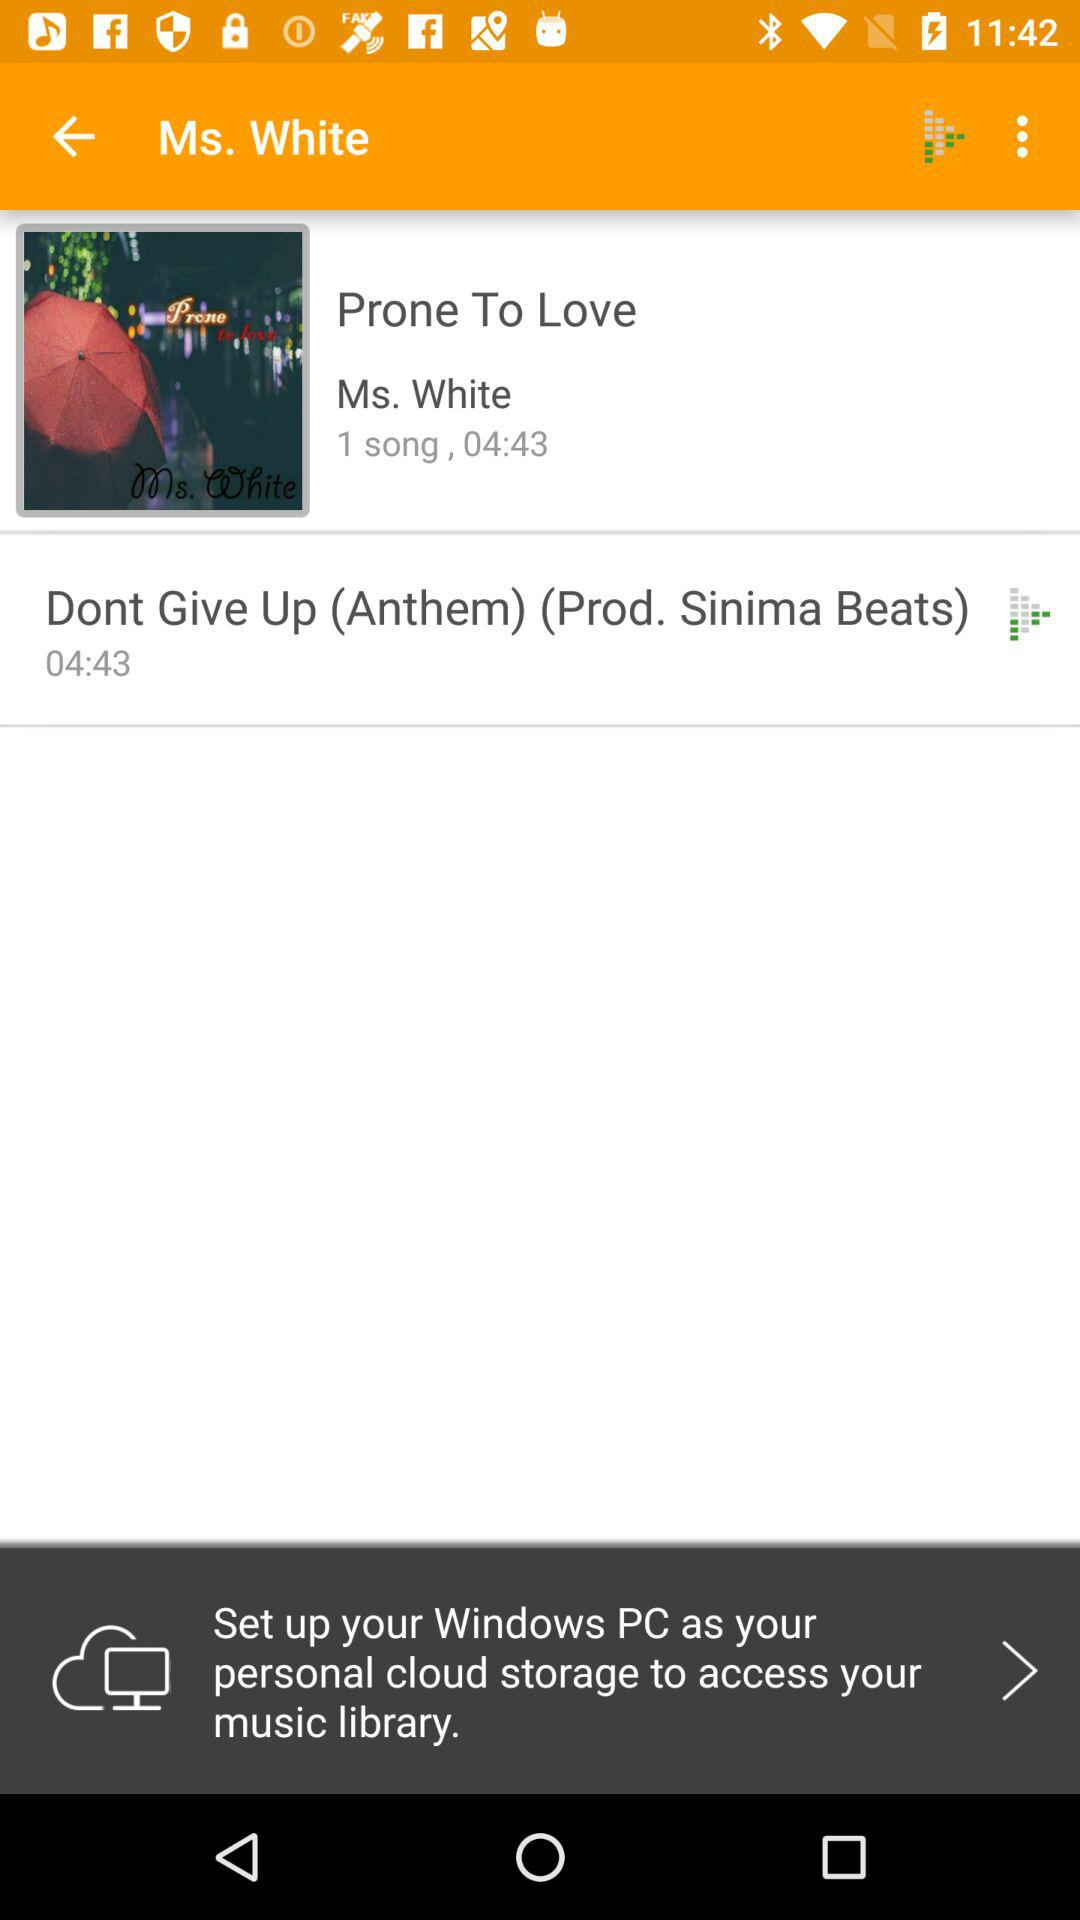What is the song name? The song name is "Dont Give Up (Anthem)". 